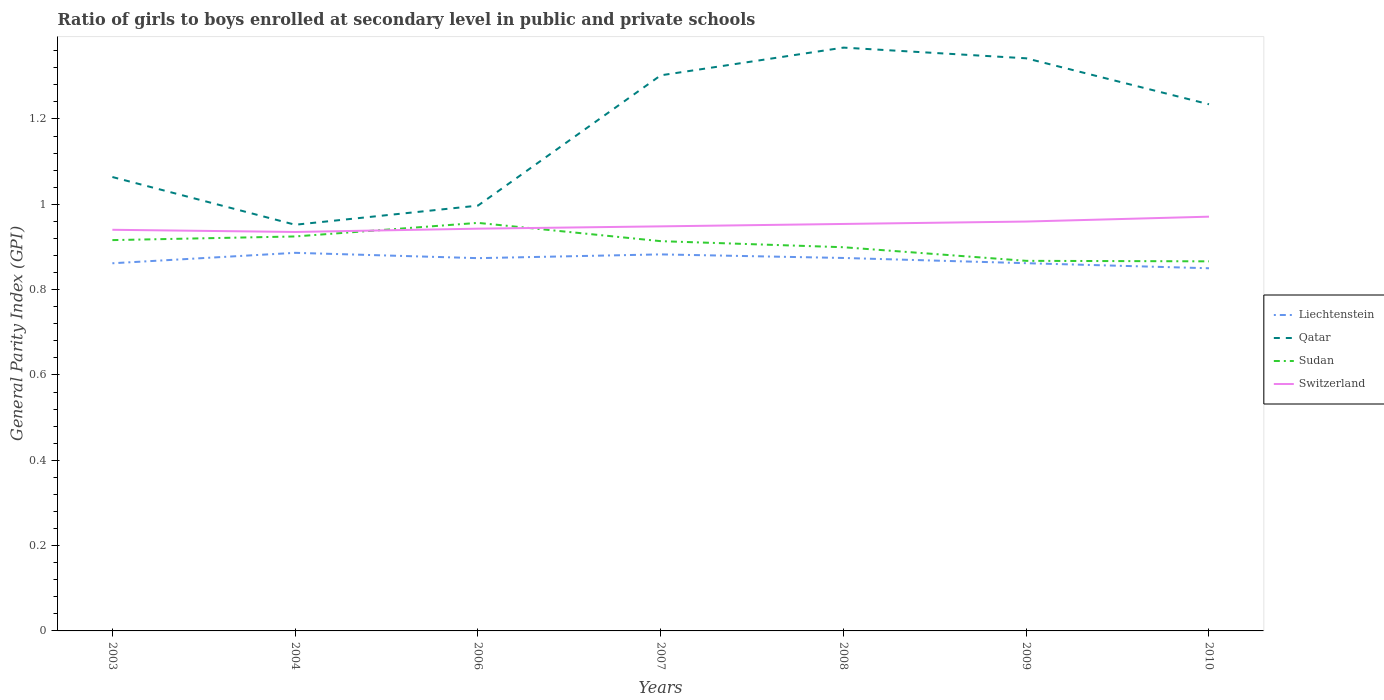Does the line corresponding to Sudan intersect with the line corresponding to Liechtenstein?
Provide a succinct answer. No. Across all years, what is the maximum general parity index in Sudan?
Make the answer very short. 0.87. In which year was the general parity index in Switzerland maximum?
Your response must be concise. 2004. What is the total general parity index in Switzerland in the graph?
Offer a terse response. -0. What is the difference between the highest and the second highest general parity index in Sudan?
Provide a short and direct response. 0.09. Is the general parity index in Qatar strictly greater than the general parity index in Liechtenstein over the years?
Keep it short and to the point. No. How many lines are there?
Offer a terse response. 4. What is the difference between two consecutive major ticks on the Y-axis?
Provide a short and direct response. 0.2. Are the values on the major ticks of Y-axis written in scientific E-notation?
Offer a very short reply. No. Does the graph contain any zero values?
Ensure brevity in your answer.  No. How many legend labels are there?
Keep it short and to the point. 4. What is the title of the graph?
Ensure brevity in your answer.  Ratio of girls to boys enrolled at secondary level in public and private schools. What is the label or title of the X-axis?
Make the answer very short. Years. What is the label or title of the Y-axis?
Offer a terse response. General Parity Index (GPI). What is the General Parity Index (GPI) in Liechtenstein in 2003?
Keep it short and to the point. 0.86. What is the General Parity Index (GPI) of Qatar in 2003?
Your response must be concise. 1.06. What is the General Parity Index (GPI) of Sudan in 2003?
Make the answer very short. 0.92. What is the General Parity Index (GPI) of Switzerland in 2003?
Your answer should be very brief. 0.94. What is the General Parity Index (GPI) in Liechtenstein in 2004?
Your answer should be compact. 0.89. What is the General Parity Index (GPI) of Qatar in 2004?
Offer a terse response. 0.95. What is the General Parity Index (GPI) of Sudan in 2004?
Your answer should be very brief. 0.92. What is the General Parity Index (GPI) in Switzerland in 2004?
Give a very brief answer. 0.94. What is the General Parity Index (GPI) of Liechtenstein in 2006?
Offer a very short reply. 0.87. What is the General Parity Index (GPI) of Qatar in 2006?
Your answer should be very brief. 1. What is the General Parity Index (GPI) of Sudan in 2006?
Ensure brevity in your answer.  0.96. What is the General Parity Index (GPI) in Switzerland in 2006?
Provide a short and direct response. 0.94. What is the General Parity Index (GPI) of Liechtenstein in 2007?
Provide a short and direct response. 0.88. What is the General Parity Index (GPI) in Qatar in 2007?
Your answer should be compact. 1.3. What is the General Parity Index (GPI) in Sudan in 2007?
Your answer should be very brief. 0.91. What is the General Parity Index (GPI) of Switzerland in 2007?
Your answer should be very brief. 0.95. What is the General Parity Index (GPI) in Liechtenstein in 2008?
Provide a short and direct response. 0.87. What is the General Parity Index (GPI) in Qatar in 2008?
Offer a very short reply. 1.37. What is the General Parity Index (GPI) of Sudan in 2008?
Your answer should be very brief. 0.9. What is the General Parity Index (GPI) of Switzerland in 2008?
Offer a terse response. 0.95. What is the General Parity Index (GPI) of Liechtenstein in 2009?
Ensure brevity in your answer.  0.86. What is the General Parity Index (GPI) in Qatar in 2009?
Give a very brief answer. 1.34. What is the General Parity Index (GPI) of Sudan in 2009?
Provide a short and direct response. 0.87. What is the General Parity Index (GPI) in Switzerland in 2009?
Your answer should be very brief. 0.96. What is the General Parity Index (GPI) of Liechtenstein in 2010?
Give a very brief answer. 0.85. What is the General Parity Index (GPI) of Qatar in 2010?
Provide a succinct answer. 1.23. What is the General Parity Index (GPI) of Sudan in 2010?
Offer a very short reply. 0.87. What is the General Parity Index (GPI) of Switzerland in 2010?
Provide a succinct answer. 0.97. Across all years, what is the maximum General Parity Index (GPI) in Liechtenstein?
Make the answer very short. 0.89. Across all years, what is the maximum General Parity Index (GPI) in Qatar?
Offer a terse response. 1.37. Across all years, what is the maximum General Parity Index (GPI) in Sudan?
Provide a short and direct response. 0.96. Across all years, what is the maximum General Parity Index (GPI) of Switzerland?
Give a very brief answer. 0.97. Across all years, what is the minimum General Parity Index (GPI) of Liechtenstein?
Offer a terse response. 0.85. Across all years, what is the minimum General Parity Index (GPI) of Qatar?
Offer a very short reply. 0.95. Across all years, what is the minimum General Parity Index (GPI) of Sudan?
Offer a very short reply. 0.87. Across all years, what is the minimum General Parity Index (GPI) in Switzerland?
Offer a very short reply. 0.94. What is the total General Parity Index (GPI) in Liechtenstein in the graph?
Give a very brief answer. 6.09. What is the total General Parity Index (GPI) in Qatar in the graph?
Offer a very short reply. 8.26. What is the total General Parity Index (GPI) in Sudan in the graph?
Offer a terse response. 6.34. What is the total General Parity Index (GPI) of Switzerland in the graph?
Offer a very short reply. 6.65. What is the difference between the General Parity Index (GPI) of Liechtenstein in 2003 and that in 2004?
Your answer should be very brief. -0.02. What is the difference between the General Parity Index (GPI) of Qatar in 2003 and that in 2004?
Provide a succinct answer. 0.11. What is the difference between the General Parity Index (GPI) of Sudan in 2003 and that in 2004?
Your answer should be compact. -0.01. What is the difference between the General Parity Index (GPI) in Switzerland in 2003 and that in 2004?
Your answer should be very brief. 0.01. What is the difference between the General Parity Index (GPI) of Liechtenstein in 2003 and that in 2006?
Make the answer very short. -0.01. What is the difference between the General Parity Index (GPI) in Qatar in 2003 and that in 2006?
Provide a short and direct response. 0.07. What is the difference between the General Parity Index (GPI) of Sudan in 2003 and that in 2006?
Make the answer very short. -0.04. What is the difference between the General Parity Index (GPI) in Switzerland in 2003 and that in 2006?
Provide a succinct answer. -0. What is the difference between the General Parity Index (GPI) of Liechtenstein in 2003 and that in 2007?
Offer a terse response. -0.02. What is the difference between the General Parity Index (GPI) of Qatar in 2003 and that in 2007?
Offer a very short reply. -0.24. What is the difference between the General Parity Index (GPI) in Sudan in 2003 and that in 2007?
Keep it short and to the point. 0. What is the difference between the General Parity Index (GPI) in Switzerland in 2003 and that in 2007?
Keep it short and to the point. -0.01. What is the difference between the General Parity Index (GPI) of Liechtenstein in 2003 and that in 2008?
Provide a short and direct response. -0.01. What is the difference between the General Parity Index (GPI) in Qatar in 2003 and that in 2008?
Make the answer very short. -0.3. What is the difference between the General Parity Index (GPI) in Sudan in 2003 and that in 2008?
Offer a terse response. 0.02. What is the difference between the General Parity Index (GPI) of Switzerland in 2003 and that in 2008?
Your answer should be very brief. -0.01. What is the difference between the General Parity Index (GPI) in Liechtenstein in 2003 and that in 2009?
Your response must be concise. -0. What is the difference between the General Parity Index (GPI) of Qatar in 2003 and that in 2009?
Your answer should be very brief. -0.28. What is the difference between the General Parity Index (GPI) of Sudan in 2003 and that in 2009?
Provide a short and direct response. 0.05. What is the difference between the General Parity Index (GPI) of Switzerland in 2003 and that in 2009?
Your response must be concise. -0.02. What is the difference between the General Parity Index (GPI) in Liechtenstein in 2003 and that in 2010?
Ensure brevity in your answer.  0.01. What is the difference between the General Parity Index (GPI) of Qatar in 2003 and that in 2010?
Offer a terse response. -0.17. What is the difference between the General Parity Index (GPI) of Sudan in 2003 and that in 2010?
Offer a very short reply. 0.05. What is the difference between the General Parity Index (GPI) in Switzerland in 2003 and that in 2010?
Your answer should be compact. -0.03. What is the difference between the General Parity Index (GPI) in Liechtenstein in 2004 and that in 2006?
Make the answer very short. 0.01. What is the difference between the General Parity Index (GPI) of Qatar in 2004 and that in 2006?
Keep it short and to the point. -0.04. What is the difference between the General Parity Index (GPI) in Sudan in 2004 and that in 2006?
Your answer should be compact. -0.03. What is the difference between the General Parity Index (GPI) in Switzerland in 2004 and that in 2006?
Ensure brevity in your answer.  -0.01. What is the difference between the General Parity Index (GPI) in Liechtenstein in 2004 and that in 2007?
Give a very brief answer. 0. What is the difference between the General Parity Index (GPI) of Qatar in 2004 and that in 2007?
Keep it short and to the point. -0.35. What is the difference between the General Parity Index (GPI) in Sudan in 2004 and that in 2007?
Ensure brevity in your answer.  0.01. What is the difference between the General Parity Index (GPI) in Switzerland in 2004 and that in 2007?
Provide a succinct answer. -0.01. What is the difference between the General Parity Index (GPI) of Liechtenstein in 2004 and that in 2008?
Your answer should be compact. 0.01. What is the difference between the General Parity Index (GPI) in Qatar in 2004 and that in 2008?
Provide a short and direct response. -0.42. What is the difference between the General Parity Index (GPI) in Sudan in 2004 and that in 2008?
Your answer should be compact. 0.03. What is the difference between the General Parity Index (GPI) of Switzerland in 2004 and that in 2008?
Offer a terse response. -0.02. What is the difference between the General Parity Index (GPI) of Liechtenstein in 2004 and that in 2009?
Make the answer very short. 0.02. What is the difference between the General Parity Index (GPI) in Qatar in 2004 and that in 2009?
Offer a terse response. -0.39. What is the difference between the General Parity Index (GPI) of Sudan in 2004 and that in 2009?
Provide a succinct answer. 0.06. What is the difference between the General Parity Index (GPI) of Switzerland in 2004 and that in 2009?
Your response must be concise. -0.02. What is the difference between the General Parity Index (GPI) of Liechtenstein in 2004 and that in 2010?
Ensure brevity in your answer.  0.04. What is the difference between the General Parity Index (GPI) of Qatar in 2004 and that in 2010?
Keep it short and to the point. -0.28. What is the difference between the General Parity Index (GPI) of Sudan in 2004 and that in 2010?
Provide a short and direct response. 0.06. What is the difference between the General Parity Index (GPI) in Switzerland in 2004 and that in 2010?
Keep it short and to the point. -0.04. What is the difference between the General Parity Index (GPI) in Liechtenstein in 2006 and that in 2007?
Your answer should be very brief. -0.01. What is the difference between the General Parity Index (GPI) of Qatar in 2006 and that in 2007?
Your answer should be very brief. -0.31. What is the difference between the General Parity Index (GPI) in Sudan in 2006 and that in 2007?
Offer a terse response. 0.04. What is the difference between the General Parity Index (GPI) in Switzerland in 2006 and that in 2007?
Make the answer very short. -0.01. What is the difference between the General Parity Index (GPI) in Liechtenstein in 2006 and that in 2008?
Provide a succinct answer. -0. What is the difference between the General Parity Index (GPI) of Qatar in 2006 and that in 2008?
Provide a short and direct response. -0.37. What is the difference between the General Parity Index (GPI) in Sudan in 2006 and that in 2008?
Provide a succinct answer. 0.06. What is the difference between the General Parity Index (GPI) in Switzerland in 2006 and that in 2008?
Provide a short and direct response. -0.01. What is the difference between the General Parity Index (GPI) in Liechtenstein in 2006 and that in 2009?
Your answer should be very brief. 0.01. What is the difference between the General Parity Index (GPI) in Qatar in 2006 and that in 2009?
Your answer should be very brief. -0.35. What is the difference between the General Parity Index (GPI) of Sudan in 2006 and that in 2009?
Offer a very short reply. 0.09. What is the difference between the General Parity Index (GPI) of Switzerland in 2006 and that in 2009?
Your response must be concise. -0.02. What is the difference between the General Parity Index (GPI) in Liechtenstein in 2006 and that in 2010?
Your answer should be compact. 0.02. What is the difference between the General Parity Index (GPI) in Qatar in 2006 and that in 2010?
Give a very brief answer. -0.24. What is the difference between the General Parity Index (GPI) of Sudan in 2006 and that in 2010?
Keep it short and to the point. 0.09. What is the difference between the General Parity Index (GPI) in Switzerland in 2006 and that in 2010?
Provide a short and direct response. -0.03. What is the difference between the General Parity Index (GPI) of Liechtenstein in 2007 and that in 2008?
Your response must be concise. 0.01. What is the difference between the General Parity Index (GPI) of Qatar in 2007 and that in 2008?
Ensure brevity in your answer.  -0.07. What is the difference between the General Parity Index (GPI) in Sudan in 2007 and that in 2008?
Your response must be concise. 0.01. What is the difference between the General Parity Index (GPI) of Switzerland in 2007 and that in 2008?
Offer a very short reply. -0.01. What is the difference between the General Parity Index (GPI) in Liechtenstein in 2007 and that in 2009?
Make the answer very short. 0.02. What is the difference between the General Parity Index (GPI) in Qatar in 2007 and that in 2009?
Your answer should be very brief. -0.04. What is the difference between the General Parity Index (GPI) of Sudan in 2007 and that in 2009?
Ensure brevity in your answer.  0.05. What is the difference between the General Parity Index (GPI) in Switzerland in 2007 and that in 2009?
Make the answer very short. -0.01. What is the difference between the General Parity Index (GPI) of Liechtenstein in 2007 and that in 2010?
Give a very brief answer. 0.03. What is the difference between the General Parity Index (GPI) in Qatar in 2007 and that in 2010?
Provide a short and direct response. 0.07. What is the difference between the General Parity Index (GPI) of Sudan in 2007 and that in 2010?
Your answer should be compact. 0.05. What is the difference between the General Parity Index (GPI) of Switzerland in 2007 and that in 2010?
Offer a very short reply. -0.02. What is the difference between the General Parity Index (GPI) in Liechtenstein in 2008 and that in 2009?
Make the answer very short. 0.01. What is the difference between the General Parity Index (GPI) in Qatar in 2008 and that in 2009?
Keep it short and to the point. 0.03. What is the difference between the General Parity Index (GPI) of Sudan in 2008 and that in 2009?
Provide a succinct answer. 0.03. What is the difference between the General Parity Index (GPI) in Switzerland in 2008 and that in 2009?
Offer a terse response. -0.01. What is the difference between the General Parity Index (GPI) of Liechtenstein in 2008 and that in 2010?
Give a very brief answer. 0.02. What is the difference between the General Parity Index (GPI) in Qatar in 2008 and that in 2010?
Your response must be concise. 0.13. What is the difference between the General Parity Index (GPI) of Sudan in 2008 and that in 2010?
Offer a very short reply. 0.03. What is the difference between the General Parity Index (GPI) of Switzerland in 2008 and that in 2010?
Keep it short and to the point. -0.02. What is the difference between the General Parity Index (GPI) in Liechtenstein in 2009 and that in 2010?
Keep it short and to the point. 0.01. What is the difference between the General Parity Index (GPI) in Qatar in 2009 and that in 2010?
Give a very brief answer. 0.11. What is the difference between the General Parity Index (GPI) in Sudan in 2009 and that in 2010?
Your answer should be compact. 0. What is the difference between the General Parity Index (GPI) of Switzerland in 2009 and that in 2010?
Provide a succinct answer. -0.01. What is the difference between the General Parity Index (GPI) of Liechtenstein in 2003 and the General Parity Index (GPI) of Qatar in 2004?
Give a very brief answer. -0.09. What is the difference between the General Parity Index (GPI) in Liechtenstein in 2003 and the General Parity Index (GPI) in Sudan in 2004?
Ensure brevity in your answer.  -0.06. What is the difference between the General Parity Index (GPI) of Liechtenstein in 2003 and the General Parity Index (GPI) of Switzerland in 2004?
Make the answer very short. -0.07. What is the difference between the General Parity Index (GPI) of Qatar in 2003 and the General Parity Index (GPI) of Sudan in 2004?
Your answer should be very brief. 0.14. What is the difference between the General Parity Index (GPI) of Qatar in 2003 and the General Parity Index (GPI) of Switzerland in 2004?
Give a very brief answer. 0.13. What is the difference between the General Parity Index (GPI) in Sudan in 2003 and the General Parity Index (GPI) in Switzerland in 2004?
Ensure brevity in your answer.  -0.02. What is the difference between the General Parity Index (GPI) of Liechtenstein in 2003 and the General Parity Index (GPI) of Qatar in 2006?
Provide a short and direct response. -0.14. What is the difference between the General Parity Index (GPI) of Liechtenstein in 2003 and the General Parity Index (GPI) of Sudan in 2006?
Offer a very short reply. -0.09. What is the difference between the General Parity Index (GPI) in Liechtenstein in 2003 and the General Parity Index (GPI) in Switzerland in 2006?
Offer a very short reply. -0.08. What is the difference between the General Parity Index (GPI) in Qatar in 2003 and the General Parity Index (GPI) in Sudan in 2006?
Offer a terse response. 0.11. What is the difference between the General Parity Index (GPI) in Qatar in 2003 and the General Parity Index (GPI) in Switzerland in 2006?
Provide a short and direct response. 0.12. What is the difference between the General Parity Index (GPI) of Sudan in 2003 and the General Parity Index (GPI) of Switzerland in 2006?
Offer a very short reply. -0.03. What is the difference between the General Parity Index (GPI) in Liechtenstein in 2003 and the General Parity Index (GPI) in Qatar in 2007?
Give a very brief answer. -0.44. What is the difference between the General Parity Index (GPI) in Liechtenstein in 2003 and the General Parity Index (GPI) in Sudan in 2007?
Provide a succinct answer. -0.05. What is the difference between the General Parity Index (GPI) of Liechtenstein in 2003 and the General Parity Index (GPI) of Switzerland in 2007?
Your answer should be compact. -0.09. What is the difference between the General Parity Index (GPI) in Qatar in 2003 and the General Parity Index (GPI) in Sudan in 2007?
Provide a succinct answer. 0.15. What is the difference between the General Parity Index (GPI) of Qatar in 2003 and the General Parity Index (GPI) of Switzerland in 2007?
Ensure brevity in your answer.  0.12. What is the difference between the General Parity Index (GPI) in Sudan in 2003 and the General Parity Index (GPI) in Switzerland in 2007?
Ensure brevity in your answer.  -0.03. What is the difference between the General Parity Index (GPI) of Liechtenstein in 2003 and the General Parity Index (GPI) of Qatar in 2008?
Provide a succinct answer. -0.51. What is the difference between the General Parity Index (GPI) of Liechtenstein in 2003 and the General Parity Index (GPI) of Sudan in 2008?
Your answer should be very brief. -0.04. What is the difference between the General Parity Index (GPI) in Liechtenstein in 2003 and the General Parity Index (GPI) in Switzerland in 2008?
Keep it short and to the point. -0.09. What is the difference between the General Parity Index (GPI) of Qatar in 2003 and the General Parity Index (GPI) of Sudan in 2008?
Your answer should be compact. 0.16. What is the difference between the General Parity Index (GPI) of Qatar in 2003 and the General Parity Index (GPI) of Switzerland in 2008?
Your response must be concise. 0.11. What is the difference between the General Parity Index (GPI) in Sudan in 2003 and the General Parity Index (GPI) in Switzerland in 2008?
Give a very brief answer. -0.04. What is the difference between the General Parity Index (GPI) of Liechtenstein in 2003 and the General Parity Index (GPI) of Qatar in 2009?
Give a very brief answer. -0.48. What is the difference between the General Parity Index (GPI) of Liechtenstein in 2003 and the General Parity Index (GPI) of Sudan in 2009?
Provide a short and direct response. -0.01. What is the difference between the General Parity Index (GPI) of Liechtenstein in 2003 and the General Parity Index (GPI) of Switzerland in 2009?
Provide a succinct answer. -0.1. What is the difference between the General Parity Index (GPI) in Qatar in 2003 and the General Parity Index (GPI) in Sudan in 2009?
Your answer should be compact. 0.2. What is the difference between the General Parity Index (GPI) of Qatar in 2003 and the General Parity Index (GPI) of Switzerland in 2009?
Provide a succinct answer. 0.1. What is the difference between the General Parity Index (GPI) of Sudan in 2003 and the General Parity Index (GPI) of Switzerland in 2009?
Offer a very short reply. -0.04. What is the difference between the General Parity Index (GPI) of Liechtenstein in 2003 and the General Parity Index (GPI) of Qatar in 2010?
Provide a short and direct response. -0.37. What is the difference between the General Parity Index (GPI) of Liechtenstein in 2003 and the General Parity Index (GPI) of Sudan in 2010?
Give a very brief answer. -0. What is the difference between the General Parity Index (GPI) of Liechtenstein in 2003 and the General Parity Index (GPI) of Switzerland in 2010?
Give a very brief answer. -0.11. What is the difference between the General Parity Index (GPI) in Qatar in 2003 and the General Parity Index (GPI) in Sudan in 2010?
Keep it short and to the point. 0.2. What is the difference between the General Parity Index (GPI) in Qatar in 2003 and the General Parity Index (GPI) in Switzerland in 2010?
Provide a succinct answer. 0.09. What is the difference between the General Parity Index (GPI) in Sudan in 2003 and the General Parity Index (GPI) in Switzerland in 2010?
Provide a succinct answer. -0.06. What is the difference between the General Parity Index (GPI) in Liechtenstein in 2004 and the General Parity Index (GPI) in Qatar in 2006?
Your answer should be very brief. -0.11. What is the difference between the General Parity Index (GPI) of Liechtenstein in 2004 and the General Parity Index (GPI) of Sudan in 2006?
Your answer should be compact. -0.07. What is the difference between the General Parity Index (GPI) of Liechtenstein in 2004 and the General Parity Index (GPI) of Switzerland in 2006?
Provide a succinct answer. -0.06. What is the difference between the General Parity Index (GPI) of Qatar in 2004 and the General Parity Index (GPI) of Sudan in 2006?
Give a very brief answer. -0. What is the difference between the General Parity Index (GPI) in Qatar in 2004 and the General Parity Index (GPI) in Switzerland in 2006?
Make the answer very short. 0.01. What is the difference between the General Parity Index (GPI) of Sudan in 2004 and the General Parity Index (GPI) of Switzerland in 2006?
Provide a succinct answer. -0.02. What is the difference between the General Parity Index (GPI) in Liechtenstein in 2004 and the General Parity Index (GPI) in Qatar in 2007?
Provide a succinct answer. -0.42. What is the difference between the General Parity Index (GPI) in Liechtenstein in 2004 and the General Parity Index (GPI) in Sudan in 2007?
Your answer should be compact. -0.03. What is the difference between the General Parity Index (GPI) in Liechtenstein in 2004 and the General Parity Index (GPI) in Switzerland in 2007?
Your response must be concise. -0.06. What is the difference between the General Parity Index (GPI) in Qatar in 2004 and the General Parity Index (GPI) in Sudan in 2007?
Provide a succinct answer. 0.04. What is the difference between the General Parity Index (GPI) in Qatar in 2004 and the General Parity Index (GPI) in Switzerland in 2007?
Make the answer very short. 0. What is the difference between the General Parity Index (GPI) of Sudan in 2004 and the General Parity Index (GPI) of Switzerland in 2007?
Ensure brevity in your answer.  -0.02. What is the difference between the General Parity Index (GPI) in Liechtenstein in 2004 and the General Parity Index (GPI) in Qatar in 2008?
Make the answer very short. -0.48. What is the difference between the General Parity Index (GPI) of Liechtenstein in 2004 and the General Parity Index (GPI) of Sudan in 2008?
Your answer should be compact. -0.01. What is the difference between the General Parity Index (GPI) of Liechtenstein in 2004 and the General Parity Index (GPI) of Switzerland in 2008?
Make the answer very short. -0.07. What is the difference between the General Parity Index (GPI) of Qatar in 2004 and the General Parity Index (GPI) of Sudan in 2008?
Provide a short and direct response. 0.05. What is the difference between the General Parity Index (GPI) in Qatar in 2004 and the General Parity Index (GPI) in Switzerland in 2008?
Provide a short and direct response. -0. What is the difference between the General Parity Index (GPI) in Sudan in 2004 and the General Parity Index (GPI) in Switzerland in 2008?
Offer a terse response. -0.03. What is the difference between the General Parity Index (GPI) in Liechtenstein in 2004 and the General Parity Index (GPI) in Qatar in 2009?
Your answer should be very brief. -0.46. What is the difference between the General Parity Index (GPI) in Liechtenstein in 2004 and the General Parity Index (GPI) in Sudan in 2009?
Ensure brevity in your answer.  0.02. What is the difference between the General Parity Index (GPI) of Liechtenstein in 2004 and the General Parity Index (GPI) of Switzerland in 2009?
Offer a very short reply. -0.07. What is the difference between the General Parity Index (GPI) of Qatar in 2004 and the General Parity Index (GPI) of Sudan in 2009?
Offer a terse response. 0.08. What is the difference between the General Parity Index (GPI) in Qatar in 2004 and the General Parity Index (GPI) in Switzerland in 2009?
Keep it short and to the point. -0.01. What is the difference between the General Parity Index (GPI) of Sudan in 2004 and the General Parity Index (GPI) of Switzerland in 2009?
Keep it short and to the point. -0.03. What is the difference between the General Parity Index (GPI) of Liechtenstein in 2004 and the General Parity Index (GPI) of Qatar in 2010?
Ensure brevity in your answer.  -0.35. What is the difference between the General Parity Index (GPI) in Liechtenstein in 2004 and the General Parity Index (GPI) in Sudan in 2010?
Ensure brevity in your answer.  0.02. What is the difference between the General Parity Index (GPI) in Liechtenstein in 2004 and the General Parity Index (GPI) in Switzerland in 2010?
Give a very brief answer. -0.08. What is the difference between the General Parity Index (GPI) of Qatar in 2004 and the General Parity Index (GPI) of Sudan in 2010?
Provide a succinct answer. 0.09. What is the difference between the General Parity Index (GPI) in Qatar in 2004 and the General Parity Index (GPI) in Switzerland in 2010?
Offer a very short reply. -0.02. What is the difference between the General Parity Index (GPI) of Sudan in 2004 and the General Parity Index (GPI) of Switzerland in 2010?
Offer a terse response. -0.05. What is the difference between the General Parity Index (GPI) of Liechtenstein in 2006 and the General Parity Index (GPI) of Qatar in 2007?
Keep it short and to the point. -0.43. What is the difference between the General Parity Index (GPI) of Liechtenstein in 2006 and the General Parity Index (GPI) of Sudan in 2007?
Provide a succinct answer. -0.04. What is the difference between the General Parity Index (GPI) in Liechtenstein in 2006 and the General Parity Index (GPI) in Switzerland in 2007?
Offer a terse response. -0.07. What is the difference between the General Parity Index (GPI) in Qatar in 2006 and the General Parity Index (GPI) in Sudan in 2007?
Make the answer very short. 0.08. What is the difference between the General Parity Index (GPI) of Qatar in 2006 and the General Parity Index (GPI) of Switzerland in 2007?
Give a very brief answer. 0.05. What is the difference between the General Parity Index (GPI) in Sudan in 2006 and the General Parity Index (GPI) in Switzerland in 2007?
Offer a terse response. 0.01. What is the difference between the General Parity Index (GPI) in Liechtenstein in 2006 and the General Parity Index (GPI) in Qatar in 2008?
Offer a terse response. -0.49. What is the difference between the General Parity Index (GPI) of Liechtenstein in 2006 and the General Parity Index (GPI) of Sudan in 2008?
Your response must be concise. -0.03. What is the difference between the General Parity Index (GPI) of Liechtenstein in 2006 and the General Parity Index (GPI) of Switzerland in 2008?
Offer a terse response. -0.08. What is the difference between the General Parity Index (GPI) in Qatar in 2006 and the General Parity Index (GPI) in Sudan in 2008?
Offer a terse response. 0.1. What is the difference between the General Parity Index (GPI) in Qatar in 2006 and the General Parity Index (GPI) in Switzerland in 2008?
Provide a short and direct response. 0.04. What is the difference between the General Parity Index (GPI) of Sudan in 2006 and the General Parity Index (GPI) of Switzerland in 2008?
Keep it short and to the point. 0. What is the difference between the General Parity Index (GPI) of Liechtenstein in 2006 and the General Parity Index (GPI) of Qatar in 2009?
Offer a terse response. -0.47. What is the difference between the General Parity Index (GPI) of Liechtenstein in 2006 and the General Parity Index (GPI) of Sudan in 2009?
Your answer should be compact. 0.01. What is the difference between the General Parity Index (GPI) in Liechtenstein in 2006 and the General Parity Index (GPI) in Switzerland in 2009?
Provide a succinct answer. -0.09. What is the difference between the General Parity Index (GPI) of Qatar in 2006 and the General Parity Index (GPI) of Sudan in 2009?
Provide a short and direct response. 0.13. What is the difference between the General Parity Index (GPI) in Qatar in 2006 and the General Parity Index (GPI) in Switzerland in 2009?
Provide a short and direct response. 0.04. What is the difference between the General Parity Index (GPI) of Sudan in 2006 and the General Parity Index (GPI) of Switzerland in 2009?
Keep it short and to the point. -0. What is the difference between the General Parity Index (GPI) of Liechtenstein in 2006 and the General Parity Index (GPI) of Qatar in 2010?
Your response must be concise. -0.36. What is the difference between the General Parity Index (GPI) in Liechtenstein in 2006 and the General Parity Index (GPI) in Sudan in 2010?
Your response must be concise. 0.01. What is the difference between the General Parity Index (GPI) in Liechtenstein in 2006 and the General Parity Index (GPI) in Switzerland in 2010?
Offer a terse response. -0.1. What is the difference between the General Parity Index (GPI) of Qatar in 2006 and the General Parity Index (GPI) of Sudan in 2010?
Keep it short and to the point. 0.13. What is the difference between the General Parity Index (GPI) of Qatar in 2006 and the General Parity Index (GPI) of Switzerland in 2010?
Keep it short and to the point. 0.03. What is the difference between the General Parity Index (GPI) in Sudan in 2006 and the General Parity Index (GPI) in Switzerland in 2010?
Provide a short and direct response. -0.01. What is the difference between the General Parity Index (GPI) in Liechtenstein in 2007 and the General Parity Index (GPI) in Qatar in 2008?
Your response must be concise. -0.48. What is the difference between the General Parity Index (GPI) of Liechtenstein in 2007 and the General Parity Index (GPI) of Sudan in 2008?
Offer a terse response. -0.02. What is the difference between the General Parity Index (GPI) in Liechtenstein in 2007 and the General Parity Index (GPI) in Switzerland in 2008?
Offer a very short reply. -0.07. What is the difference between the General Parity Index (GPI) in Qatar in 2007 and the General Parity Index (GPI) in Sudan in 2008?
Give a very brief answer. 0.4. What is the difference between the General Parity Index (GPI) in Qatar in 2007 and the General Parity Index (GPI) in Switzerland in 2008?
Ensure brevity in your answer.  0.35. What is the difference between the General Parity Index (GPI) of Sudan in 2007 and the General Parity Index (GPI) of Switzerland in 2008?
Provide a short and direct response. -0.04. What is the difference between the General Parity Index (GPI) of Liechtenstein in 2007 and the General Parity Index (GPI) of Qatar in 2009?
Provide a succinct answer. -0.46. What is the difference between the General Parity Index (GPI) of Liechtenstein in 2007 and the General Parity Index (GPI) of Sudan in 2009?
Provide a succinct answer. 0.02. What is the difference between the General Parity Index (GPI) in Liechtenstein in 2007 and the General Parity Index (GPI) in Switzerland in 2009?
Your answer should be very brief. -0.08. What is the difference between the General Parity Index (GPI) in Qatar in 2007 and the General Parity Index (GPI) in Sudan in 2009?
Your answer should be compact. 0.43. What is the difference between the General Parity Index (GPI) of Qatar in 2007 and the General Parity Index (GPI) of Switzerland in 2009?
Your response must be concise. 0.34. What is the difference between the General Parity Index (GPI) of Sudan in 2007 and the General Parity Index (GPI) of Switzerland in 2009?
Offer a very short reply. -0.05. What is the difference between the General Parity Index (GPI) of Liechtenstein in 2007 and the General Parity Index (GPI) of Qatar in 2010?
Your response must be concise. -0.35. What is the difference between the General Parity Index (GPI) in Liechtenstein in 2007 and the General Parity Index (GPI) in Sudan in 2010?
Your answer should be very brief. 0.02. What is the difference between the General Parity Index (GPI) in Liechtenstein in 2007 and the General Parity Index (GPI) in Switzerland in 2010?
Offer a very short reply. -0.09. What is the difference between the General Parity Index (GPI) in Qatar in 2007 and the General Parity Index (GPI) in Sudan in 2010?
Provide a succinct answer. 0.44. What is the difference between the General Parity Index (GPI) in Qatar in 2007 and the General Parity Index (GPI) in Switzerland in 2010?
Your response must be concise. 0.33. What is the difference between the General Parity Index (GPI) in Sudan in 2007 and the General Parity Index (GPI) in Switzerland in 2010?
Your answer should be very brief. -0.06. What is the difference between the General Parity Index (GPI) of Liechtenstein in 2008 and the General Parity Index (GPI) of Qatar in 2009?
Provide a succinct answer. -0.47. What is the difference between the General Parity Index (GPI) of Liechtenstein in 2008 and the General Parity Index (GPI) of Sudan in 2009?
Your answer should be compact. 0.01. What is the difference between the General Parity Index (GPI) in Liechtenstein in 2008 and the General Parity Index (GPI) in Switzerland in 2009?
Provide a short and direct response. -0.09. What is the difference between the General Parity Index (GPI) in Qatar in 2008 and the General Parity Index (GPI) in Sudan in 2009?
Give a very brief answer. 0.5. What is the difference between the General Parity Index (GPI) of Qatar in 2008 and the General Parity Index (GPI) of Switzerland in 2009?
Keep it short and to the point. 0.41. What is the difference between the General Parity Index (GPI) in Sudan in 2008 and the General Parity Index (GPI) in Switzerland in 2009?
Your answer should be compact. -0.06. What is the difference between the General Parity Index (GPI) in Liechtenstein in 2008 and the General Parity Index (GPI) in Qatar in 2010?
Your answer should be compact. -0.36. What is the difference between the General Parity Index (GPI) of Liechtenstein in 2008 and the General Parity Index (GPI) of Sudan in 2010?
Ensure brevity in your answer.  0.01. What is the difference between the General Parity Index (GPI) of Liechtenstein in 2008 and the General Parity Index (GPI) of Switzerland in 2010?
Keep it short and to the point. -0.1. What is the difference between the General Parity Index (GPI) in Qatar in 2008 and the General Parity Index (GPI) in Sudan in 2010?
Ensure brevity in your answer.  0.5. What is the difference between the General Parity Index (GPI) in Qatar in 2008 and the General Parity Index (GPI) in Switzerland in 2010?
Provide a succinct answer. 0.4. What is the difference between the General Parity Index (GPI) in Sudan in 2008 and the General Parity Index (GPI) in Switzerland in 2010?
Keep it short and to the point. -0.07. What is the difference between the General Parity Index (GPI) of Liechtenstein in 2009 and the General Parity Index (GPI) of Qatar in 2010?
Your response must be concise. -0.37. What is the difference between the General Parity Index (GPI) of Liechtenstein in 2009 and the General Parity Index (GPI) of Sudan in 2010?
Your answer should be very brief. -0. What is the difference between the General Parity Index (GPI) of Liechtenstein in 2009 and the General Parity Index (GPI) of Switzerland in 2010?
Your answer should be compact. -0.11. What is the difference between the General Parity Index (GPI) in Qatar in 2009 and the General Parity Index (GPI) in Sudan in 2010?
Provide a succinct answer. 0.48. What is the difference between the General Parity Index (GPI) of Qatar in 2009 and the General Parity Index (GPI) of Switzerland in 2010?
Make the answer very short. 0.37. What is the difference between the General Parity Index (GPI) in Sudan in 2009 and the General Parity Index (GPI) in Switzerland in 2010?
Keep it short and to the point. -0.1. What is the average General Parity Index (GPI) in Liechtenstein per year?
Provide a succinct answer. 0.87. What is the average General Parity Index (GPI) in Qatar per year?
Make the answer very short. 1.18. What is the average General Parity Index (GPI) of Sudan per year?
Your answer should be very brief. 0.91. What is the average General Parity Index (GPI) in Switzerland per year?
Ensure brevity in your answer.  0.95. In the year 2003, what is the difference between the General Parity Index (GPI) of Liechtenstein and General Parity Index (GPI) of Qatar?
Offer a terse response. -0.2. In the year 2003, what is the difference between the General Parity Index (GPI) of Liechtenstein and General Parity Index (GPI) of Sudan?
Provide a succinct answer. -0.05. In the year 2003, what is the difference between the General Parity Index (GPI) in Liechtenstein and General Parity Index (GPI) in Switzerland?
Your response must be concise. -0.08. In the year 2003, what is the difference between the General Parity Index (GPI) in Qatar and General Parity Index (GPI) in Sudan?
Ensure brevity in your answer.  0.15. In the year 2003, what is the difference between the General Parity Index (GPI) of Qatar and General Parity Index (GPI) of Switzerland?
Offer a very short reply. 0.12. In the year 2003, what is the difference between the General Parity Index (GPI) in Sudan and General Parity Index (GPI) in Switzerland?
Ensure brevity in your answer.  -0.02. In the year 2004, what is the difference between the General Parity Index (GPI) of Liechtenstein and General Parity Index (GPI) of Qatar?
Give a very brief answer. -0.07. In the year 2004, what is the difference between the General Parity Index (GPI) in Liechtenstein and General Parity Index (GPI) in Sudan?
Provide a short and direct response. -0.04. In the year 2004, what is the difference between the General Parity Index (GPI) of Liechtenstein and General Parity Index (GPI) of Switzerland?
Offer a very short reply. -0.05. In the year 2004, what is the difference between the General Parity Index (GPI) in Qatar and General Parity Index (GPI) in Sudan?
Your answer should be very brief. 0.03. In the year 2004, what is the difference between the General Parity Index (GPI) of Qatar and General Parity Index (GPI) of Switzerland?
Make the answer very short. 0.02. In the year 2004, what is the difference between the General Parity Index (GPI) of Sudan and General Parity Index (GPI) of Switzerland?
Provide a succinct answer. -0.01. In the year 2006, what is the difference between the General Parity Index (GPI) in Liechtenstein and General Parity Index (GPI) in Qatar?
Give a very brief answer. -0.12. In the year 2006, what is the difference between the General Parity Index (GPI) in Liechtenstein and General Parity Index (GPI) in Sudan?
Offer a very short reply. -0.08. In the year 2006, what is the difference between the General Parity Index (GPI) in Liechtenstein and General Parity Index (GPI) in Switzerland?
Your answer should be compact. -0.07. In the year 2006, what is the difference between the General Parity Index (GPI) in Qatar and General Parity Index (GPI) in Sudan?
Offer a very short reply. 0.04. In the year 2006, what is the difference between the General Parity Index (GPI) of Qatar and General Parity Index (GPI) of Switzerland?
Make the answer very short. 0.05. In the year 2006, what is the difference between the General Parity Index (GPI) of Sudan and General Parity Index (GPI) of Switzerland?
Keep it short and to the point. 0.01. In the year 2007, what is the difference between the General Parity Index (GPI) of Liechtenstein and General Parity Index (GPI) of Qatar?
Give a very brief answer. -0.42. In the year 2007, what is the difference between the General Parity Index (GPI) of Liechtenstein and General Parity Index (GPI) of Sudan?
Make the answer very short. -0.03. In the year 2007, what is the difference between the General Parity Index (GPI) of Liechtenstein and General Parity Index (GPI) of Switzerland?
Make the answer very short. -0.07. In the year 2007, what is the difference between the General Parity Index (GPI) in Qatar and General Parity Index (GPI) in Sudan?
Your response must be concise. 0.39. In the year 2007, what is the difference between the General Parity Index (GPI) in Qatar and General Parity Index (GPI) in Switzerland?
Your answer should be compact. 0.35. In the year 2007, what is the difference between the General Parity Index (GPI) of Sudan and General Parity Index (GPI) of Switzerland?
Provide a succinct answer. -0.03. In the year 2008, what is the difference between the General Parity Index (GPI) in Liechtenstein and General Parity Index (GPI) in Qatar?
Provide a succinct answer. -0.49. In the year 2008, what is the difference between the General Parity Index (GPI) in Liechtenstein and General Parity Index (GPI) in Sudan?
Provide a short and direct response. -0.03. In the year 2008, what is the difference between the General Parity Index (GPI) in Liechtenstein and General Parity Index (GPI) in Switzerland?
Provide a short and direct response. -0.08. In the year 2008, what is the difference between the General Parity Index (GPI) in Qatar and General Parity Index (GPI) in Sudan?
Make the answer very short. 0.47. In the year 2008, what is the difference between the General Parity Index (GPI) of Qatar and General Parity Index (GPI) of Switzerland?
Make the answer very short. 0.41. In the year 2008, what is the difference between the General Parity Index (GPI) in Sudan and General Parity Index (GPI) in Switzerland?
Provide a succinct answer. -0.05. In the year 2009, what is the difference between the General Parity Index (GPI) of Liechtenstein and General Parity Index (GPI) of Qatar?
Provide a short and direct response. -0.48. In the year 2009, what is the difference between the General Parity Index (GPI) in Liechtenstein and General Parity Index (GPI) in Sudan?
Your answer should be very brief. -0.01. In the year 2009, what is the difference between the General Parity Index (GPI) in Liechtenstein and General Parity Index (GPI) in Switzerland?
Your answer should be very brief. -0.1. In the year 2009, what is the difference between the General Parity Index (GPI) of Qatar and General Parity Index (GPI) of Sudan?
Give a very brief answer. 0.47. In the year 2009, what is the difference between the General Parity Index (GPI) in Qatar and General Parity Index (GPI) in Switzerland?
Provide a short and direct response. 0.38. In the year 2009, what is the difference between the General Parity Index (GPI) of Sudan and General Parity Index (GPI) of Switzerland?
Your answer should be compact. -0.09. In the year 2010, what is the difference between the General Parity Index (GPI) of Liechtenstein and General Parity Index (GPI) of Qatar?
Offer a very short reply. -0.38. In the year 2010, what is the difference between the General Parity Index (GPI) of Liechtenstein and General Parity Index (GPI) of Sudan?
Ensure brevity in your answer.  -0.02. In the year 2010, what is the difference between the General Parity Index (GPI) of Liechtenstein and General Parity Index (GPI) of Switzerland?
Your answer should be compact. -0.12. In the year 2010, what is the difference between the General Parity Index (GPI) in Qatar and General Parity Index (GPI) in Sudan?
Offer a very short reply. 0.37. In the year 2010, what is the difference between the General Parity Index (GPI) in Qatar and General Parity Index (GPI) in Switzerland?
Offer a terse response. 0.26. In the year 2010, what is the difference between the General Parity Index (GPI) of Sudan and General Parity Index (GPI) of Switzerland?
Provide a succinct answer. -0.1. What is the ratio of the General Parity Index (GPI) in Liechtenstein in 2003 to that in 2004?
Make the answer very short. 0.97. What is the ratio of the General Parity Index (GPI) of Qatar in 2003 to that in 2004?
Offer a very short reply. 1.12. What is the ratio of the General Parity Index (GPI) in Liechtenstein in 2003 to that in 2006?
Your answer should be very brief. 0.99. What is the ratio of the General Parity Index (GPI) of Qatar in 2003 to that in 2006?
Your response must be concise. 1.07. What is the ratio of the General Parity Index (GPI) in Sudan in 2003 to that in 2006?
Make the answer very short. 0.96. What is the ratio of the General Parity Index (GPI) in Switzerland in 2003 to that in 2006?
Your answer should be very brief. 1. What is the ratio of the General Parity Index (GPI) of Liechtenstein in 2003 to that in 2007?
Offer a terse response. 0.98. What is the ratio of the General Parity Index (GPI) in Qatar in 2003 to that in 2007?
Your answer should be compact. 0.82. What is the ratio of the General Parity Index (GPI) of Liechtenstein in 2003 to that in 2008?
Your response must be concise. 0.99. What is the ratio of the General Parity Index (GPI) in Qatar in 2003 to that in 2008?
Ensure brevity in your answer.  0.78. What is the ratio of the General Parity Index (GPI) of Sudan in 2003 to that in 2008?
Offer a terse response. 1.02. What is the ratio of the General Parity Index (GPI) in Switzerland in 2003 to that in 2008?
Provide a succinct answer. 0.99. What is the ratio of the General Parity Index (GPI) of Liechtenstein in 2003 to that in 2009?
Keep it short and to the point. 1. What is the ratio of the General Parity Index (GPI) in Qatar in 2003 to that in 2009?
Your answer should be compact. 0.79. What is the ratio of the General Parity Index (GPI) in Sudan in 2003 to that in 2009?
Provide a succinct answer. 1.06. What is the ratio of the General Parity Index (GPI) in Switzerland in 2003 to that in 2009?
Offer a very short reply. 0.98. What is the ratio of the General Parity Index (GPI) of Liechtenstein in 2003 to that in 2010?
Your response must be concise. 1.01. What is the ratio of the General Parity Index (GPI) of Qatar in 2003 to that in 2010?
Keep it short and to the point. 0.86. What is the ratio of the General Parity Index (GPI) in Sudan in 2003 to that in 2010?
Offer a terse response. 1.06. What is the ratio of the General Parity Index (GPI) of Switzerland in 2003 to that in 2010?
Keep it short and to the point. 0.97. What is the ratio of the General Parity Index (GPI) in Liechtenstein in 2004 to that in 2006?
Ensure brevity in your answer.  1.01. What is the ratio of the General Parity Index (GPI) of Qatar in 2004 to that in 2006?
Keep it short and to the point. 0.96. What is the ratio of the General Parity Index (GPI) of Sudan in 2004 to that in 2006?
Your answer should be compact. 0.97. What is the ratio of the General Parity Index (GPI) in Qatar in 2004 to that in 2007?
Make the answer very short. 0.73. What is the ratio of the General Parity Index (GPI) in Sudan in 2004 to that in 2007?
Provide a short and direct response. 1.01. What is the ratio of the General Parity Index (GPI) in Switzerland in 2004 to that in 2007?
Ensure brevity in your answer.  0.99. What is the ratio of the General Parity Index (GPI) of Liechtenstein in 2004 to that in 2008?
Ensure brevity in your answer.  1.01. What is the ratio of the General Parity Index (GPI) of Qatar in 2004 to that in 2008?
Provide a short and direct response. 0.7. What is the ratio of the General Parity Index (GPI) of Sudan in 2004 to that in 2008?
Your response must be concise. 1.03. What is the ratio of the General Parity Index (GPI) in Switzerland in 2004 to that in 2008?
Make the answer very short. 0.98. What is the ratio of the General Parity Index (GPI) of Liechtenstein in 2004 to that in 2009?
Provide a short and direct response. 1.03. What is the ratio of the General Parity Index (GPI) of Qatar in 2004 to that in 2009?
Your answer should be compact. 0.71. What is the ratio of the General Parity Index (GPI) in Sudan in 2004 to that in 2009?
Provide a short and direct response. 1.07. What is the ratio of the General Parity Index (GPI) in Switzerland in 2004 to that in 2009?
Provide a succinct answer. 0.97. What is the ratio of the General Parity Index (GPI) of Liechtenstein in 2004 to that in 2010?
Your response must be concise. 1.04. What is the ratio of the General Parity Index (GPI) of Qatar in 2004 to that in 2010?
Ensure brevity in your answer.  0.77. What is the ratio of the General Parity Index (GPI) in Sudan in 2004 to that in 2010?
Offer a terse response. 1.07. What is the ratio of the General Parity Index (GPI) in Switzerland in 2004 to that in 2010?
Your answer should be compact. 0.96. What is the ratio of the General Parity Index (GPI) of Qatar in 2006 to that in 2007?
Give a very brief answer. 0.77. What is the ratio of the General Parity Index (GPI) in Sudan in 2006 to that in 2007?
Ensure brevity in your answer.  1.05. What is the ratio of the General Parity Index (GPI) in Switzerland in 2006 to that in 2007?
Offer a terse response. 0.99. What is the ratio of the General Parity Index (GPI) of Liechtenstein in 2006 to that in 2008?
Give a very brief answer. 1. What is the ratio of the General Parity Index (GPI) in Qatar in 2006 to that in 2008?
Keep it short and to the point. 0.73. What is the ratio of the General Parity Index (GPI) in Sudan in 2006 to that in 2008?
Provide a succinct answer. 1.06. What is the ratio of the General Parity Index (GPI) of Switzerland in 2006 to that in 2008?
Offer a very short reply. 0.99. What is the ratio of the General Parity Index (GPI) in Liechtenstein in 2006 to that in 2009?
Offer a terse response. 1.01. What is the ratio of the General Parity Index (GPI) of Qatar in 2006 to that in 2009?
Keep it short and to the point. 0.74. What is the ratio of the General Parity Index (GPI) in Sudan in 2006 to that in 2009?
Offer a terse response. 1.1. What is the ratio of the General Parity Index (GPI) in Switzerland in 2006 to that in 2009?
Provide a short and direct response. 0.98. What is the ratio of the General Parity Index (GPI) in Liechtenstein in 2006 to that in 2010?
Make the answer very short. 1.03. What is the ratio of the General Parity Index (GPI) of Qatar in 2006 to that in 2010?
Your response must be concise. 0.81. What is the ratio of the General Parity Index (GPI) of Sudan in 2006 to that in 2010?
Your answer should be very brief. 1.1. What is the ratio of the General Parity Index (GPI) of Switzerland in 2006 to that in 2010?
Your answer should be compact. 0.97. What is the ratio of the General Parity Index (GPI) in Liechtenstein in 2007 to that in 2008?
Offer a terse response. 1.01. What is the ratio of the General Parity Index (GPI) of Qatar in 2007 to that in 2008?
Your answer should be very brief. 0.95. What is the ratio of the General Parity Index (GPI) in Sudan in 2007 to that in 2008?
Keep it short and to the point. 1.02. What is the ratio of the General Parity Index (GPI) in Switzerland in 2007 to that in 2008?
Provide a short and direct response. 0.99. What is the ratio of the General Parity Index (GPI) in Liechtenstein in 2007 to that in 2009?
Ensure brevity in your answer.  1.02. What is the ratio of the General Parity Index (GPI) in Qatar in 2007 to that in 2009?
Keep it short and to the point. 0.97. What is the ratio of the General Parity Index (GPI) in Sudan in 2007 to that in 2009?
Keep it short and to the point. 1.05. What is the ratio of the General Parity Index (GPI) in Switzerland in 2007 to that in 2009?
Offer a very short reply. 0.99. What is the ratio of the General Parity Index (GPI) in Liechtenstein in 2007 to that in 2010?
Offer a very short reply. 1.04. What is the ratio of the General Parity Index (GPI) of Qatar in 2007 to that in 2010?
Your answer should be compact. 1.05. What is the ratio of the General Parity Index (GPI) in Sudan in 2007 to that in 2010?
Make the answer very short. 1.05. What is the ratio of the General Parity Index (GPI) of Switzerland in 2007 to that in 2010?
Offer a very short reply. 0.98. What is the ratio of the General Parity Index (GPI) of Liechtenstein in 2008 to that in 2009?
Offer a terse response. 1.01. What is the ratio of the General Parity Index (GPI) of Qatar in 2008 to that in 2009?
Keep it short and to the point. 1.02. What is the ratio of the General Parity Index (GPI) of Sudan in 2008 to that in 2009?
Make the answer very short. 1.04. What is the ratio of the General Parity Index (GPI) in Switzerland in 2008 to that in 2009?
Your response must be concise. 0.99. What is the ratio of the General Parity Index (GPI) in Liechtenstein in 2008 to that in 2010?
Offer a very short reply. 1.03. What is the ratio of the General Parity Index (GPI) of Qatar in 2008 to that in 2010?
Your answer should be very brief. 1.11. What is the ratio of the General Parity Index (GPI) of Sudan in 2008 to that in 2010?
Your response must be concise. 1.04. What is the ratio of the General Parity Index (GPI) of Switzerland in 2008 to that in 2010?
Ensure brevity in your answer.  0.98. What is the ratio of the General Parity Index (GPI) in Liechtenstein in 2009 to that in 2010?
Your response must be concise. 1.01. What is the ratio of the General Parity Index (GPI) in Qatar in 2009 to that in 2010?
Ensure brevity in your answer.  1.09. What is the ratio of the General Parity Index (GPI) of Switzerland in 2009 to that in 2010?
Offer a terse response. 0.99. What is the difference between the highest and the second highest General Parity Index (GPI) in Liechtenstein?
Your answer should be compact. 0. What is the difference between the highest and the second highest General Parity Index (GPI) in Qatar?
Offer a terse response. 0.03. What is the difference between the highest and the second highest General Parity Index (GPI) of Sudan?
Provide a short and direct response. 0.03. What is the difference between the highest and the second highest General Parity Index (GPI) in Switzerland?
Provide a short and direct response. 0.01. What is the difference between the highest and the lowest General Parity Index (GPI) in Liechtenstein?
Provide a succinct answer. 0.04. What is the difference between the highest and the lowest General Parity Index (GPI) in Qatar?
Make the answer very short. 0.42. What is the difference between the highest and the lowest General Parity Index (GPI) in Sudan?
Your answer should be very brief. 0.09. What is the difference between the highest and the lowest General Parity Index (GPI) in Switzerland?
Provide a succinct answer. 0.04. 